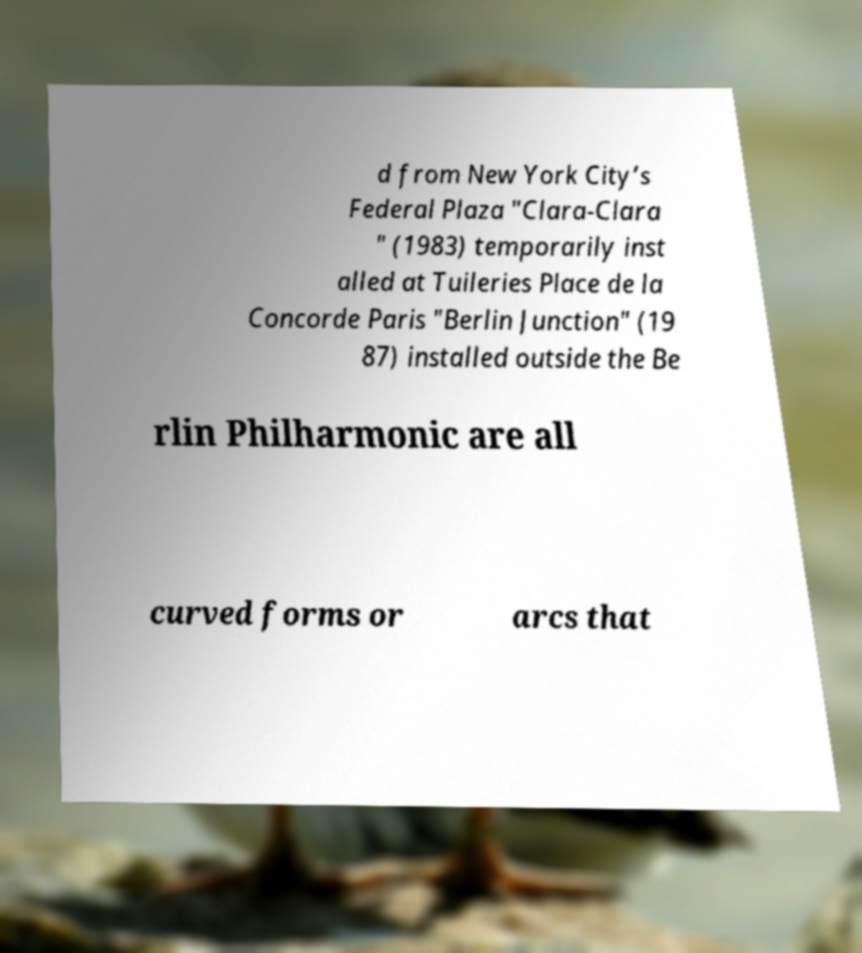Please identify and transcribe the text found in this image. d from New York City’s Federal Plaza "Clara-Clara " (1983) temporarily inst alled at Tuileries Place de la Concorde Paris "Berlin Junction" (19 87) installed outside the Be rlin Philharmonic are all curved forms or arcs that 